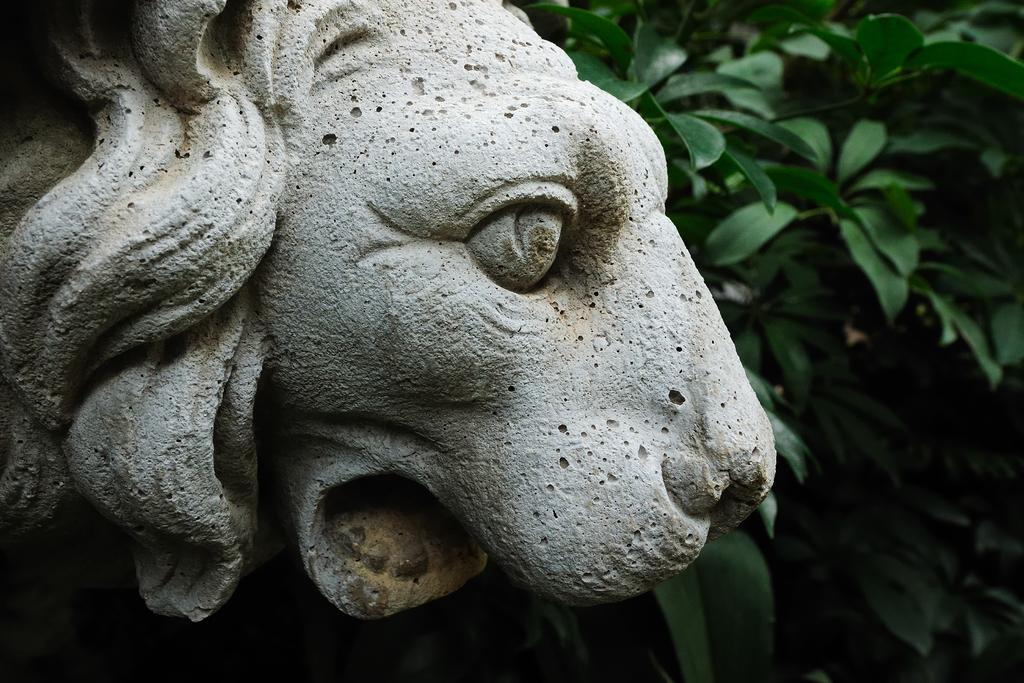What animal is depicted in the image? There is a depiction of a lion in the image. What else can be seen in the image besides the lion? There are plants beside the depiction of the lion. How many bubbles are surrounding the lion in the image? There are no bubbles present in the image; it only features a depiction of a lion and plants. 